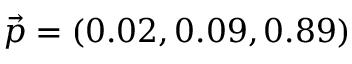<formula> <loc_0><loc_0><loc_500><loc_500>\vec { p } = ( 0 . 0 2 , 0 . 0 9 , 0 . 8 9 )</formula> 